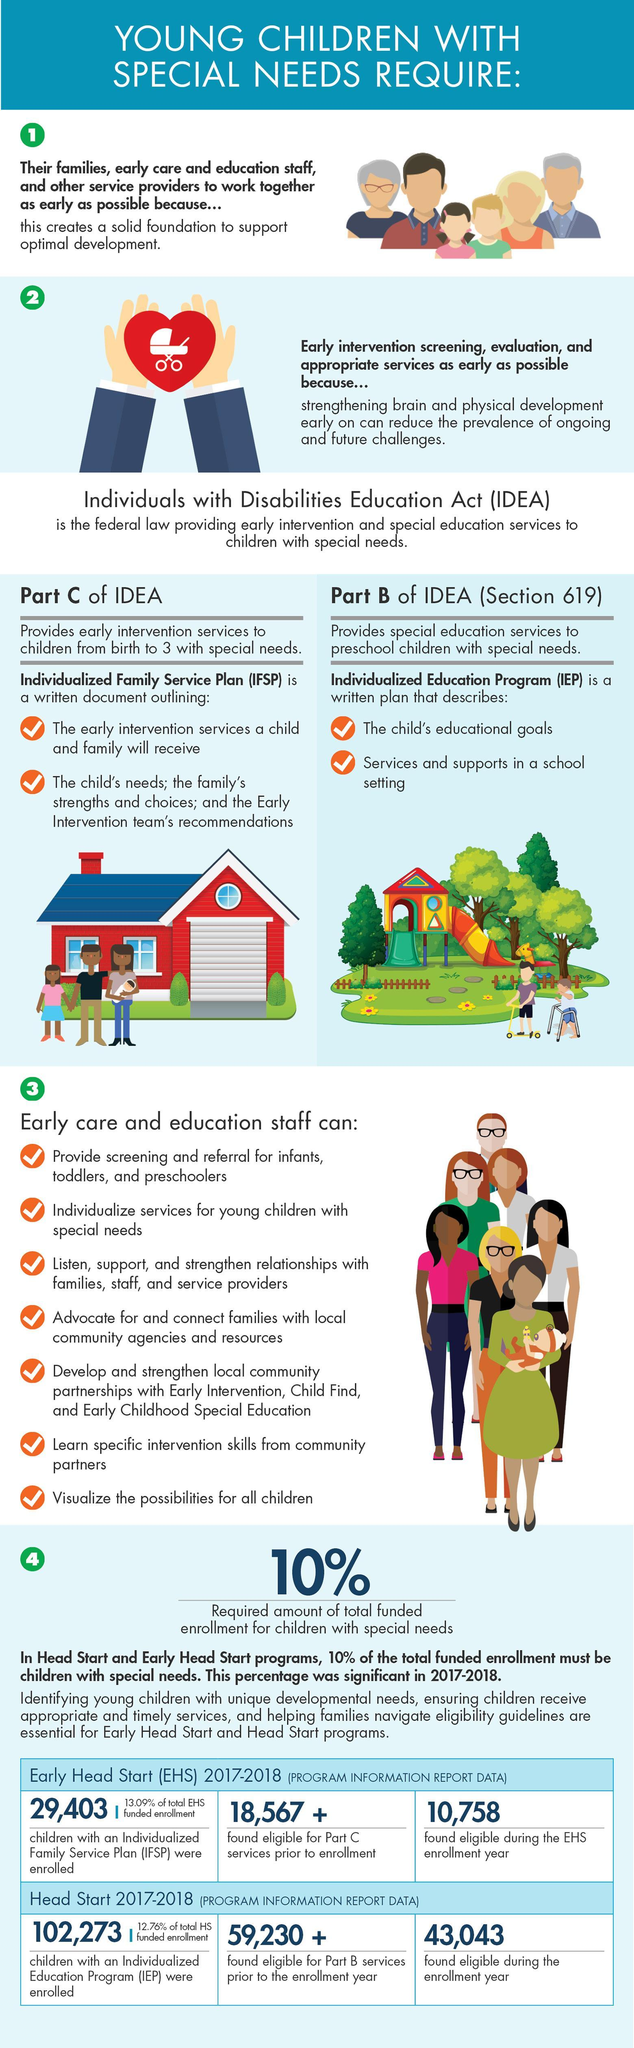How many children were found eligible during the Head Start enrollment year?
Answer the question with a short phrase. 43,043 How many children were found eligible during the EHS enrollment year? 10,758 How many children were found eligible for Part C services prior to the enrollment year in EHS 2017-18? 18,567 + How many children were found eligible for Part B services prior to the enrollment year in Head Start Program 2017-18? 59,230 + 